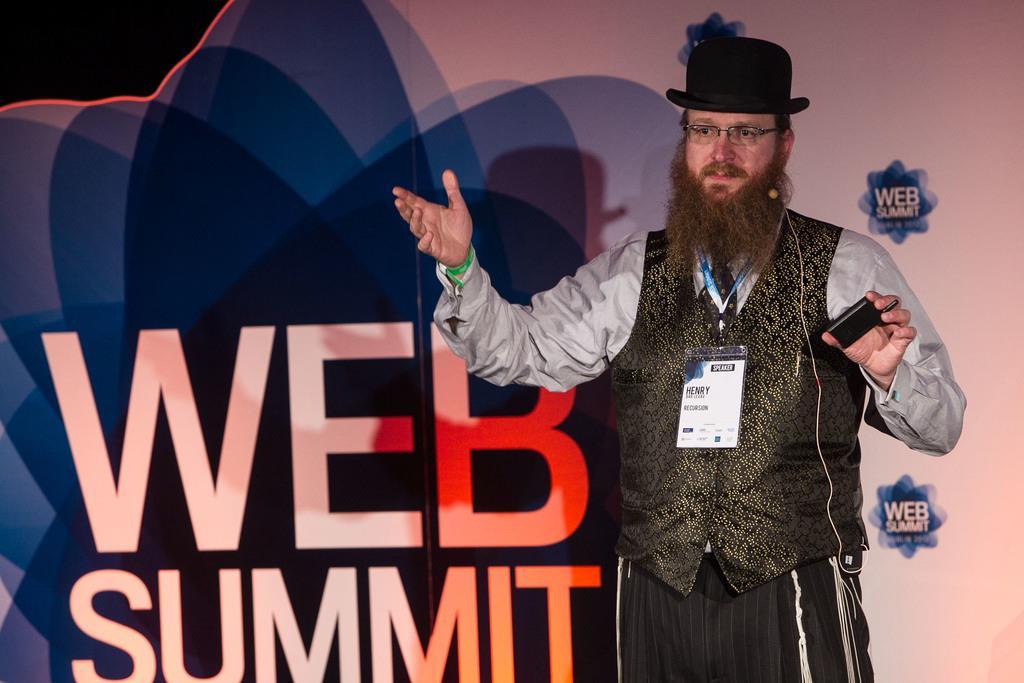How would you summarize this image in a sentence or two? To the right side of the image there is a person standing wearing a cap. In the background of the image there is a banner with some text on it. 